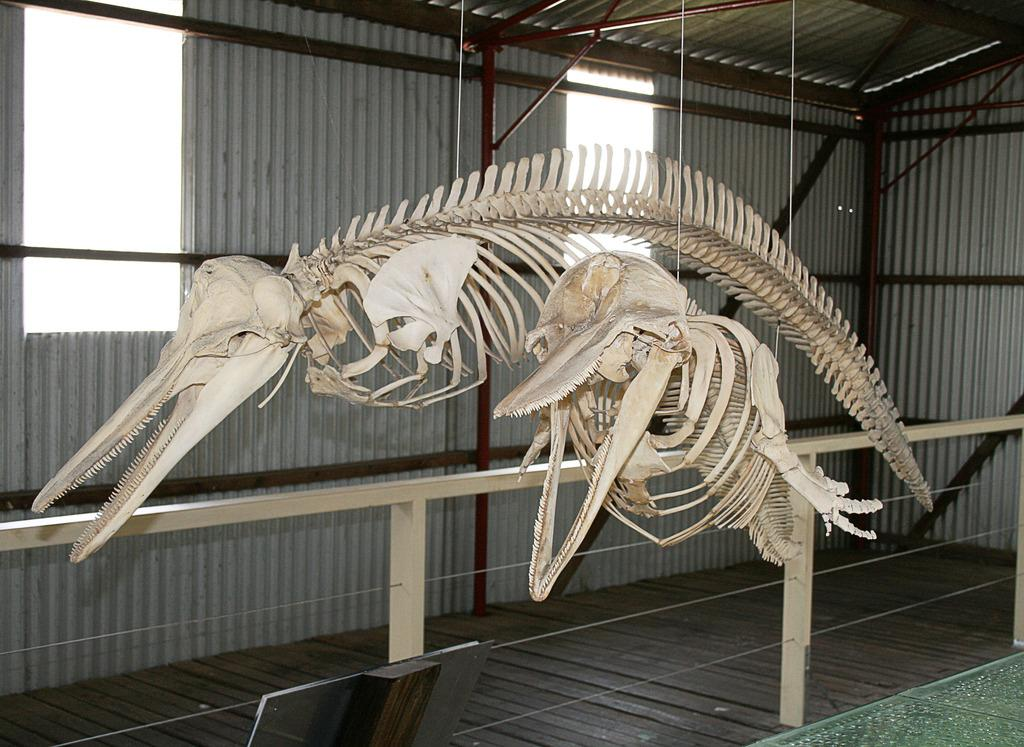What is hanging from threads in the image? There are skeletons hung with threads in the image. What type of structure can be seen in the image? There is a railing with wooden pieces in the image. What material are the walls made of in the background of the image? There are asbestos walls in the background of the image. What type of construction material is present in the image? There are iron rods in the image. What allows light and air to enter the space in the image? There are windows in the image. Where is the market located in the image? There is no market present in the image. What type of lock is used on the windows in the image? There is no lock visible on the windows in the image. 